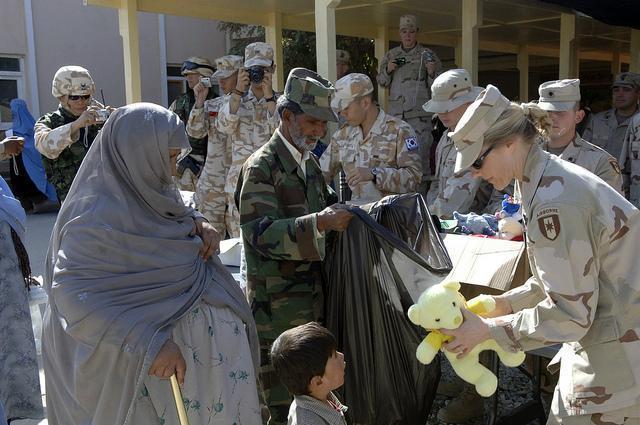How many people can be seen?
Give a very brief answer. 13. How many cakes are there?
Give a very brief answer. 0. 